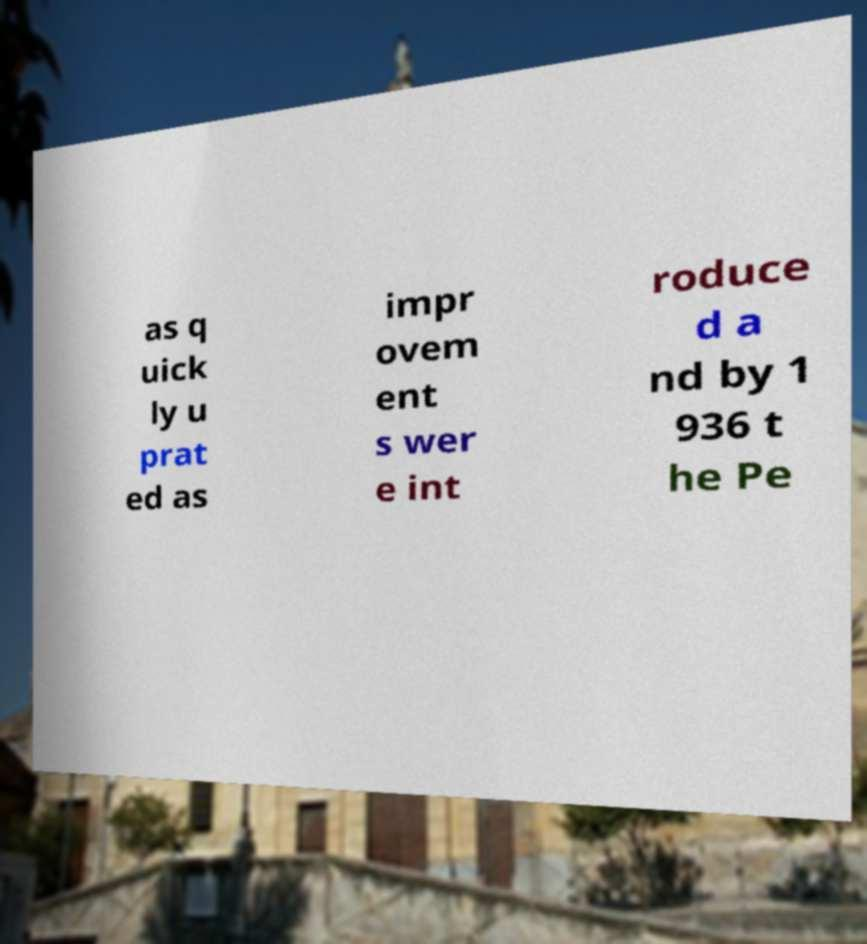Could you assist in decoding the text presented in this image and type it out clearly? as q uick ly u prat ed as impr ovem ent s wer e int roduce d a nd by 1 936 t he Pe 